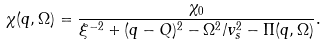Convert formula to latex. <formula><loc_0><loc_0><loc_500><loc_500>\chi ( { q } , \Omega ) = \frac { \chi _ { 0 } } { \xi ^ { - 2 } + ( { q } - { Q } ) ^ { 2 } - \Omega ^ { 2 } / v ^ { 2 } _ { s } - \Pi ( { q } , \Omega ) } .</formula> 